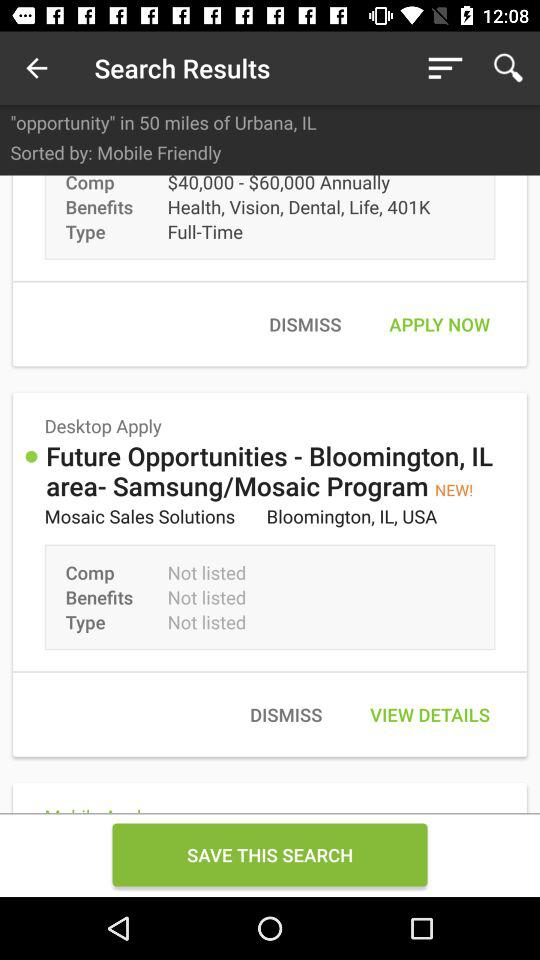What is the mentioned location for "Future Opportunities"? The mentioned location for "Future Opportunities" is Bloomington, IL, USA. 